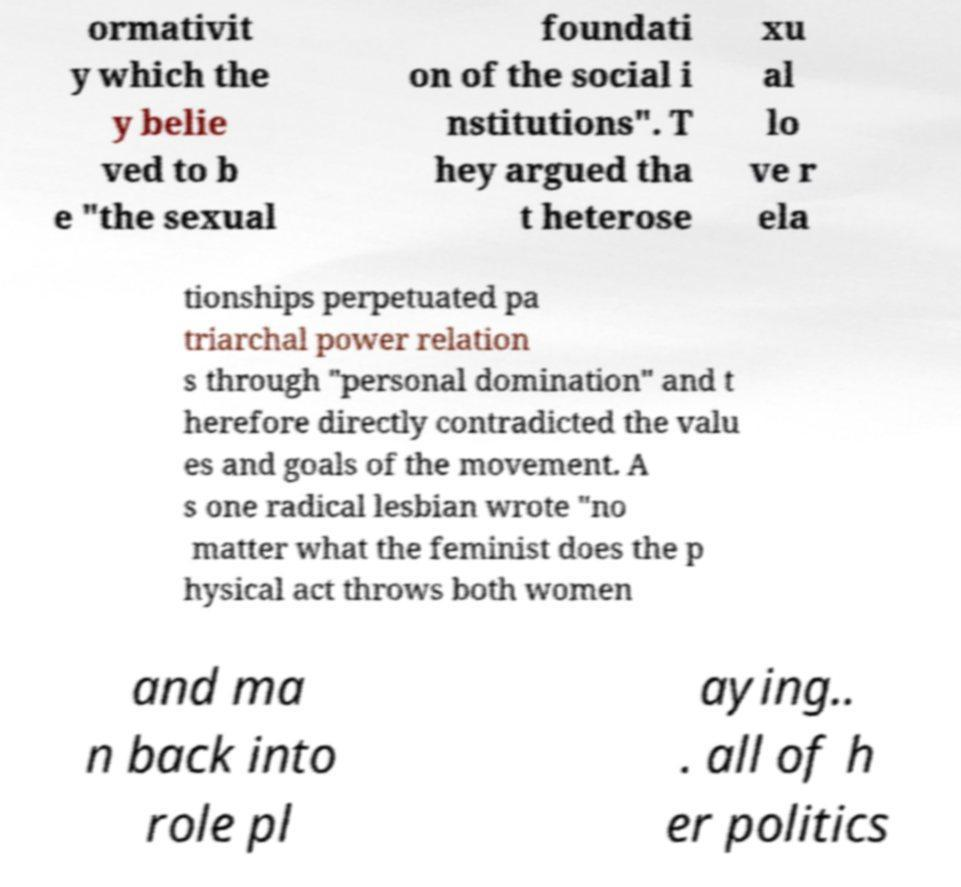Could you extract and type out the text from this image? ormativit y which the y belie ved to b e "the sexual foundati on of the social i nstitutions". T hey argued tha t heterose xu al lo ve r ela tionships perpetuated pa triarchal power relation s through "personal domination" and t herefore directly contradicted the valu es and goals of the movement. A s one radical lesbian wrote "no matter what the feminist does the p hysical act throws both women and ma n back into role pl aying.. . all of h er politics 